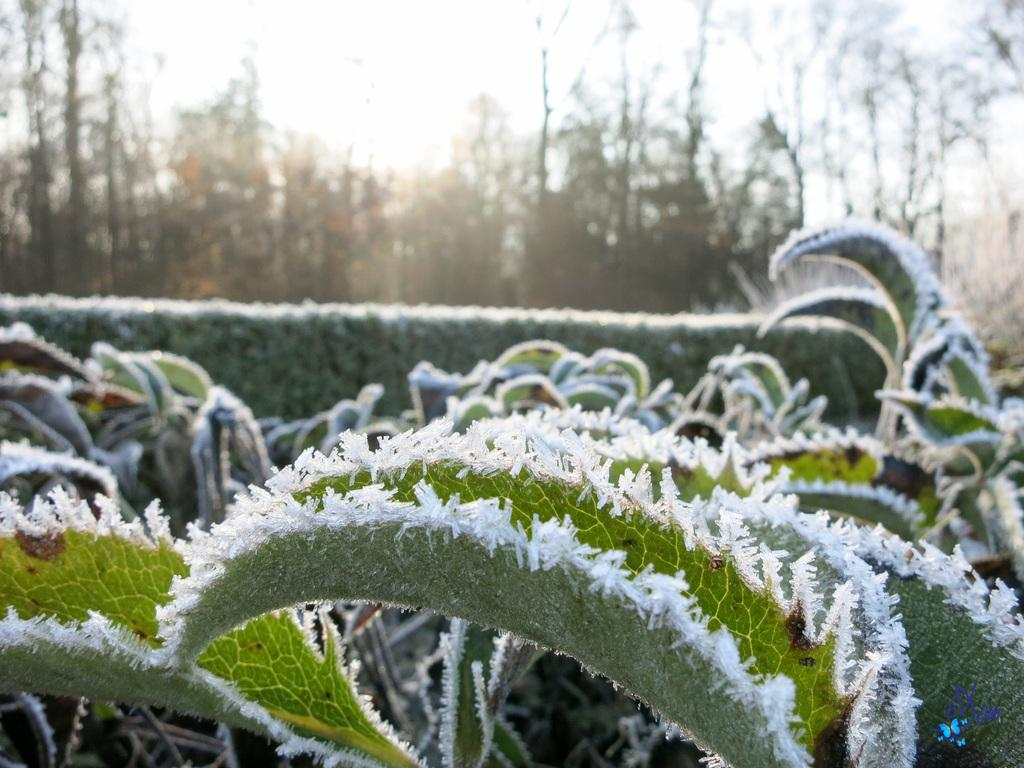What type of vegetation is in the front of the image? There are plants in the front of the image. What type of vegetation is in the background of the image? There are trees in the background of the image. What is visible at the top of the image? The sky is visible at the top of the image. What type of rod can be seen in the image? There is no rod present in the image. Is there a baby visible in the image? No, there is no baby present in the image. 